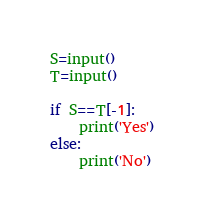Convert code to text. <code><loc_0><loc_0><loc_500><loc_500><_Python_>S=input()
T=input()

if S==T[-1]:
    print('Yes')
else:
    print('No')</code> 